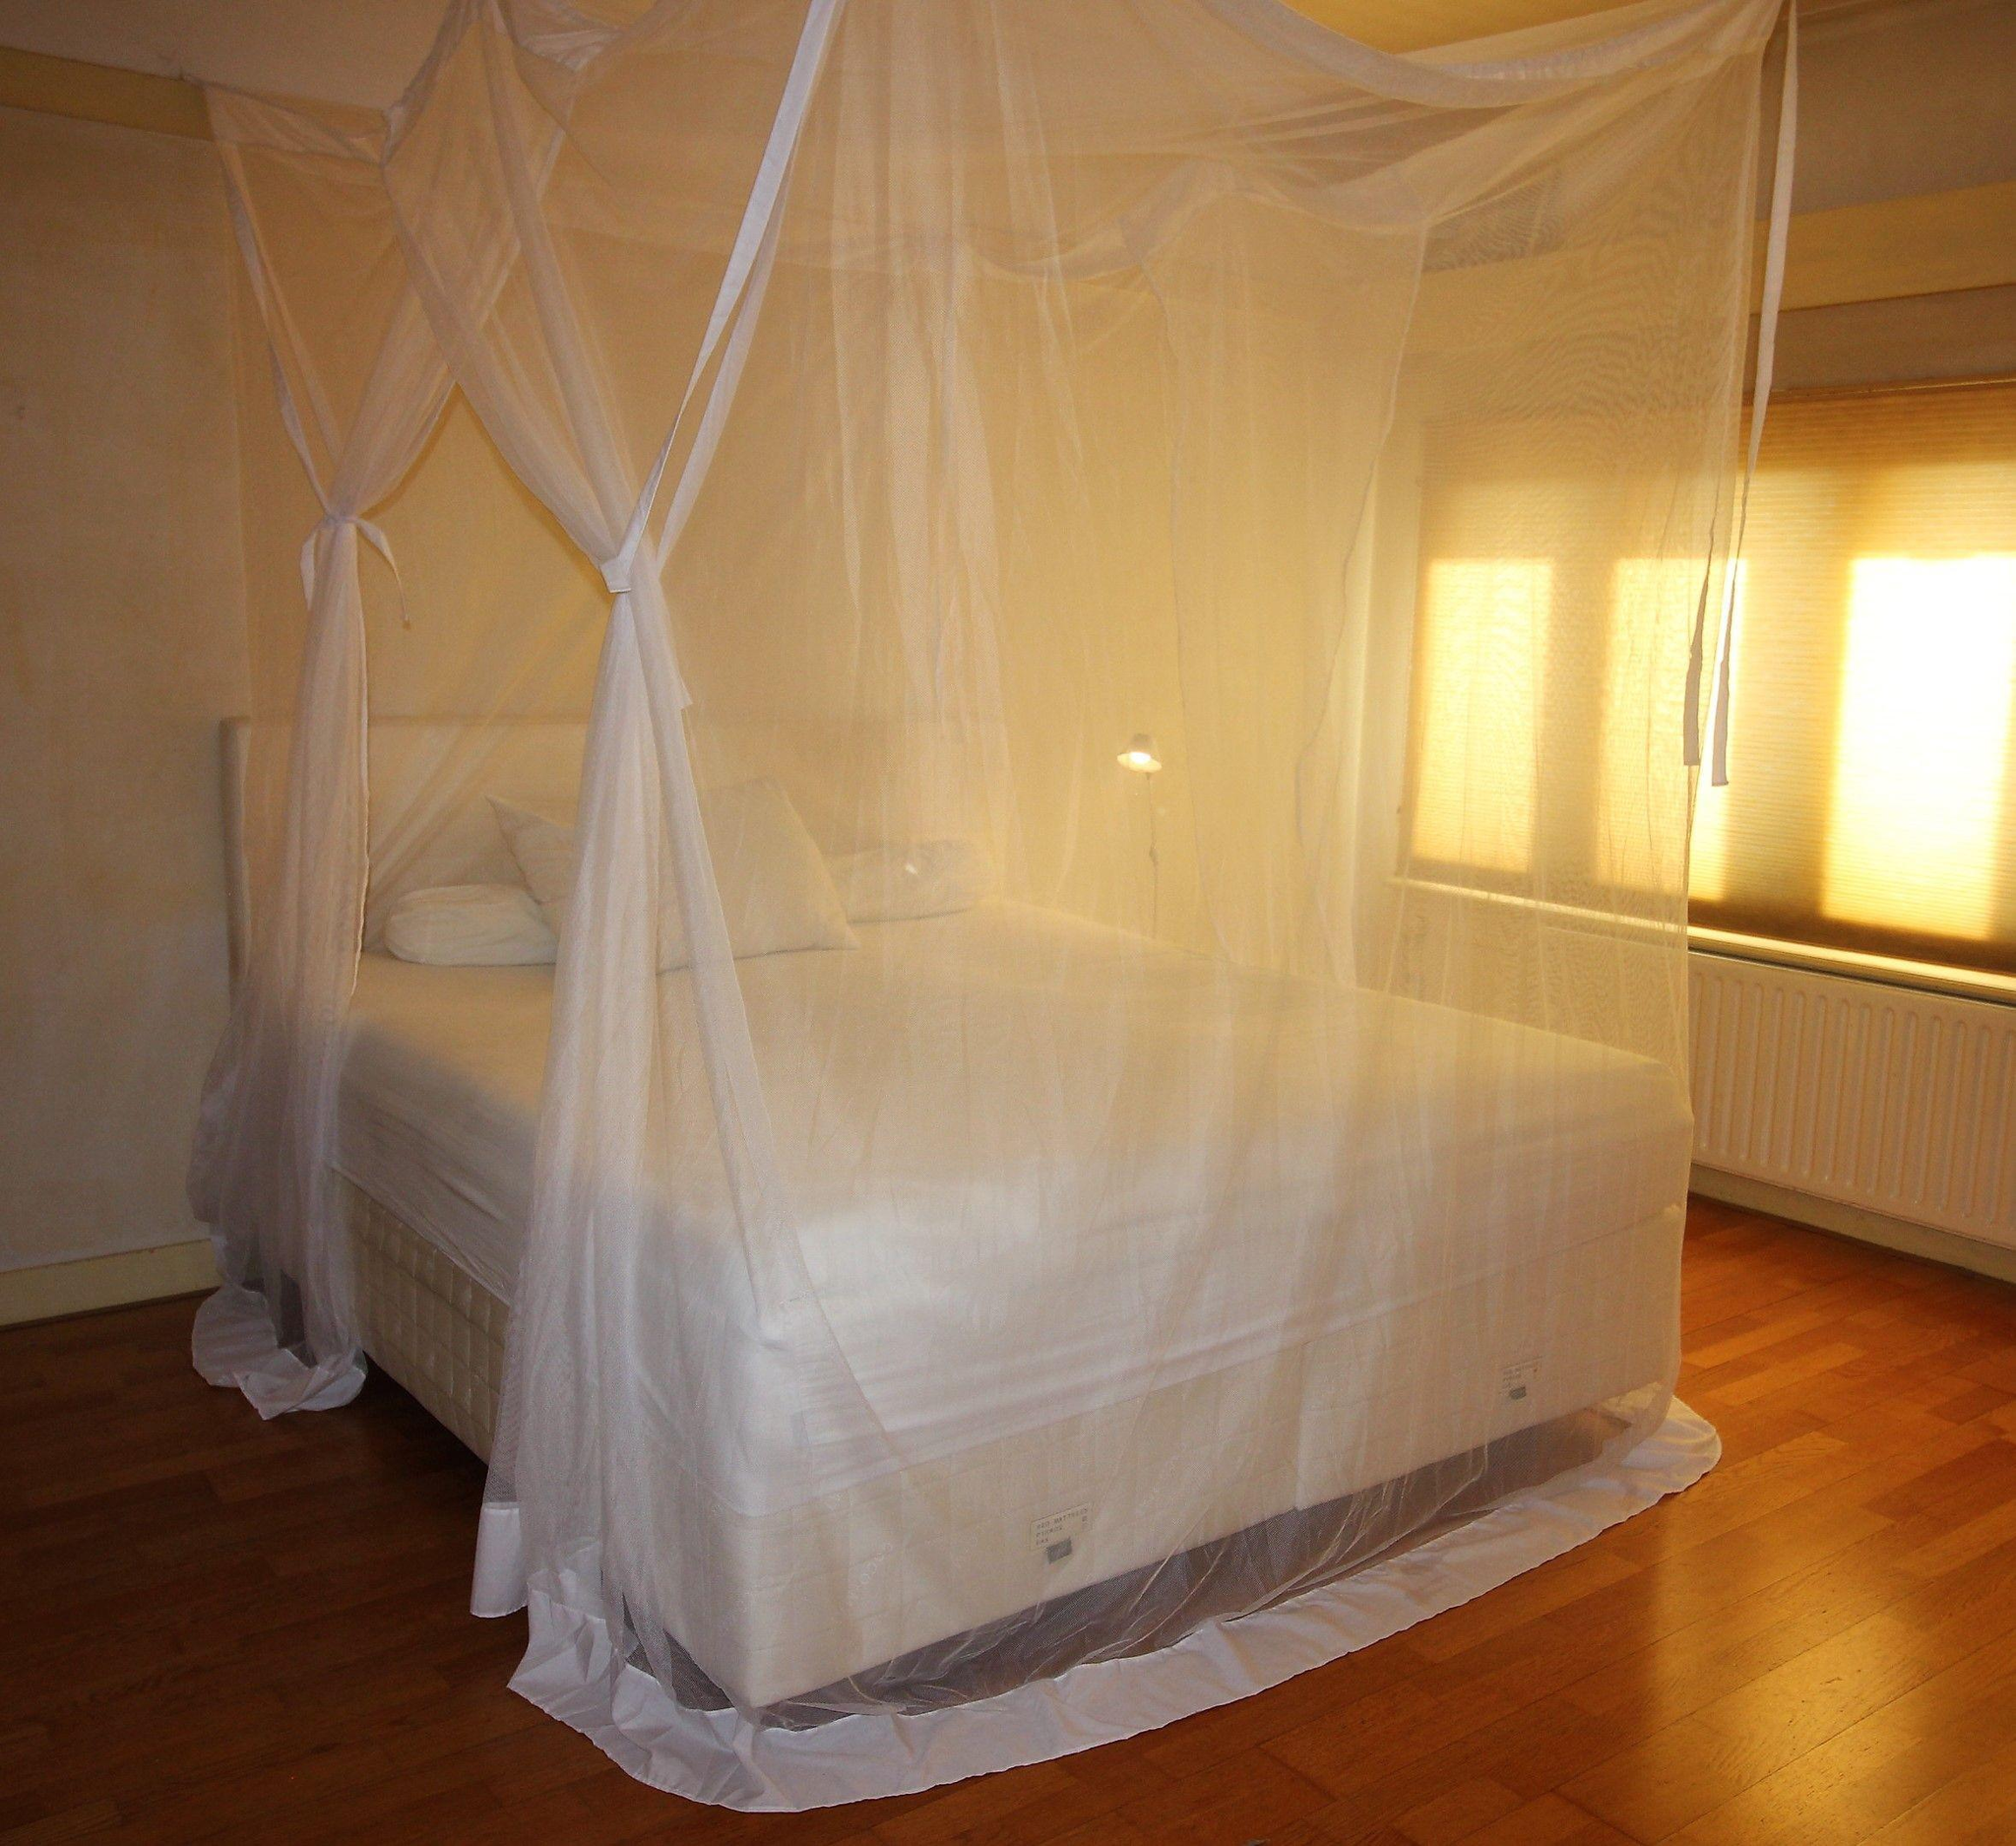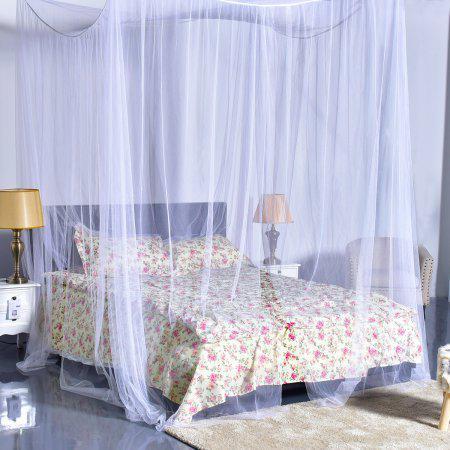The first image is the image on the left, the second image is the image on the right. Considering the images on both sides, is "The canopy bed in the left image is by a window showing daylight outside." valid? Answer yes or no. Yes. 